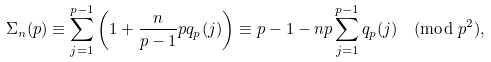Convert formula to latex. <formula><loc_0><loc_0><loc_500><loc_500>\Sigma _ { n } ( p ) \equiv \sum _ { j = 1 } ^ { p - 1 } \left ( 1 + \frac { n } { p - 1 } p q _ { p } ( j ) \right ) & \equiv p - 1 - n p \sum _ { j = 1 } ^ { p - 1 } q _ { p } ( j ) \pmod { p ^ { 2 } } ,</formula> 